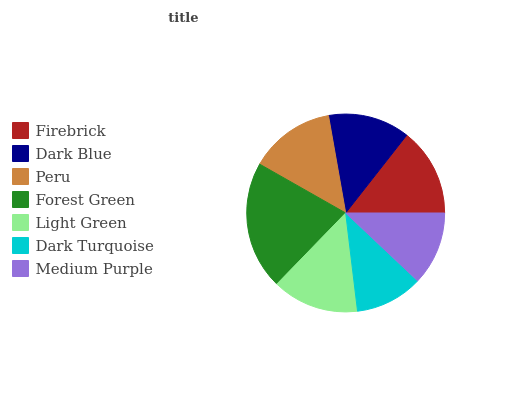Is Dark Turquoise the minimum?
Answer yes or no. Yes. Is Forest Green the maximum?
Answer yes or no. Yes. Is Dark Blue the minimum?
Answer yes or no. No. Is Dark Blue the maximum?
Answer yes or no. No. Is Firebrick greater than Dark Blue?
Answer yes or no. Yes. Is Dark Blue less than Firebrick?
Answer yes or no. Yes. Is Dark Blue greater than Firebrick?
Answer yes or no. No. Is Firebrick less than Dark Blue?
Answer yes or no. No. Is Peru the high median?
Answer yes or no. Yes. Is Peru the low median?
Answer yes or no. Yes. Is Dark Blue the high median?
Answer yes or no. No. Is Medium Purple the low median?
Answer yes or no. No. 